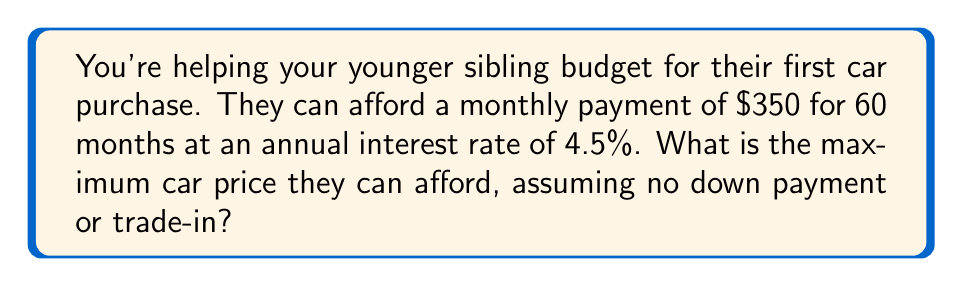Help me with this question. Let's approach this step-by-step:

1) First, we need to convert the annual interest rate to a monthly rate:
   Monthly rate = Annual rate ÷ 12
   $r = 0.045 \div 12 = 0.00375$ or 0.375% per month

2) We'll use the present value formula for an annuity:
   $PV = PMT \times \frac{1 - (1 + r)^{-n}}{r}$

   Where:
   $PV$ = Present Value (the car price we're solving for)
   $PMT$ = Monthly Payment ($350)
   $r$ = Monthly interest rate (0.00375)
   $n$ = Number of months (60)

3) Let's substitute these values into the formula:
   $PV = 350 \times \frac{1 - (1 + 0.00375)^{-60}}{0.00375}$

4) Now we can calculate:
   $PV = 350 \times \frac{1 - (1.00375)^{-60}}{0.00375}$
   $PV = 350 \times \frac{1 - 0.7987}{0.00375}$
   $PV = 350 \times 53.6933$
   $PV = 18,792.66$

5) Rounding down to the nearest whole dollar (since we don't want to exceed the budget):
   Maximum car price = $18,792
Answer: $18,792 